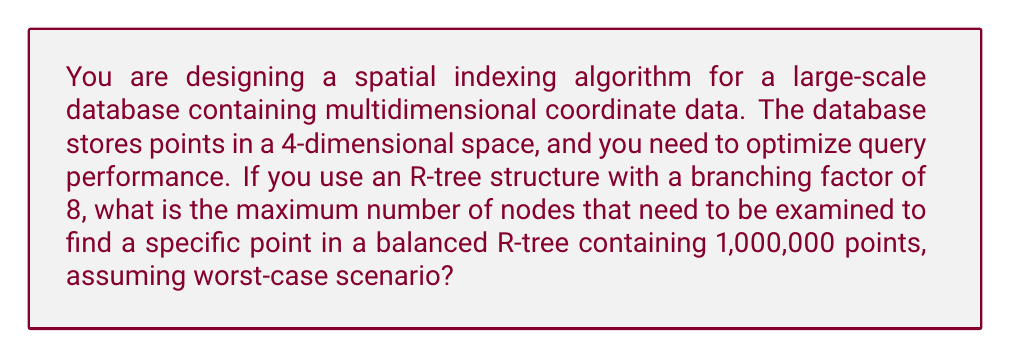Help me with this question. To solve this problem, we need to follow these steps:

1. Understand the R-tree structure:
   R-trees are hierarchical data structures used for spatial indexing. Each non-leaf node contains a set of rectangles (or hyper-rectangles in higher dimensions) that fully contain all the rectangles in its child nodes.

2. Calculate the height of the R-tree:
   With a branching factor of 8, each internal node can have up to 8 children.
   Let $h$ be the height of the tree.
   The number of leaf nodes is at most $8^{h-1}$, as we start counting from 1 for the root.

3. Find the minimum height that can accommodate 1,000,000 points:
   We need to solve the inequality:
   $$8^{h-1} \geq 1,000,000$$

   Taking the logarithm base 8 on both sides:
   $$h-1 \geq \log_8(1,000,000)$$
   $$h \geq \log_8(1,000,000) + 1$$

   $$\log_8(1,000,000) = \frac{\log(1,000,000)}{\log(8)} \approx 6.62$$

   Therefore, the minimum height $h$ that satisfies the inequality is 8.

4. In the worst-case scenario, we might need to examine one node at each level of the tree, from the root to a leaf.

5. The maximum number of nodes examined is equal to the height of the tree.
Answer: 8 nodes 